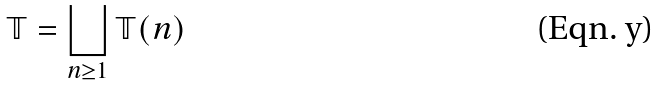Convert formula to latex. <formula><loc_0><loc_0><loc_500><loc_500>\mathbb { T } = \bigsqcup _ { n \geq 1 } \mathbb { T } ( n )</formula> 